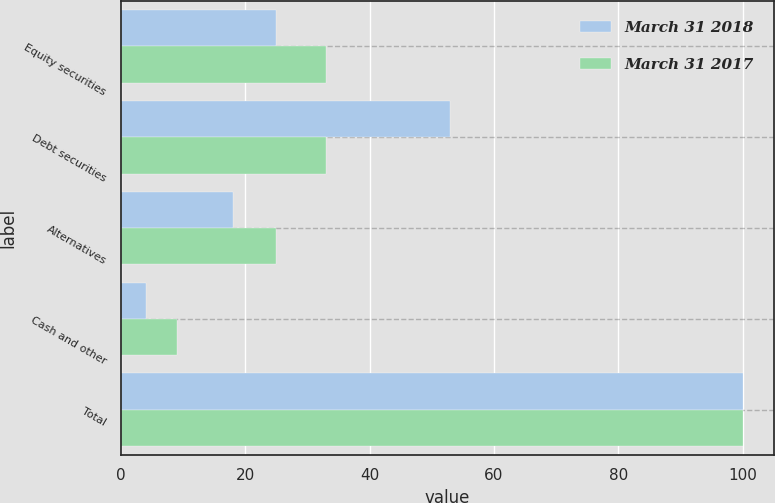Convert chart to OTSL. <chart><loc_0><loc_0><loc_500><loc_500><stacked_bar_chart><ecel><fcel>Equity securities<fcel>Debt securities<fcel>Alternatives<fcel>Cash and other<fcel>Total<nl><fcel>March 31 2018<fcel>25<fcel>53<fcel>18<fcel>4<fcel>100<nl><fcel>March 31 2017<fcel>33<fcel>33<fcel>25<fcel>9<fcel>100<nl></chart> 